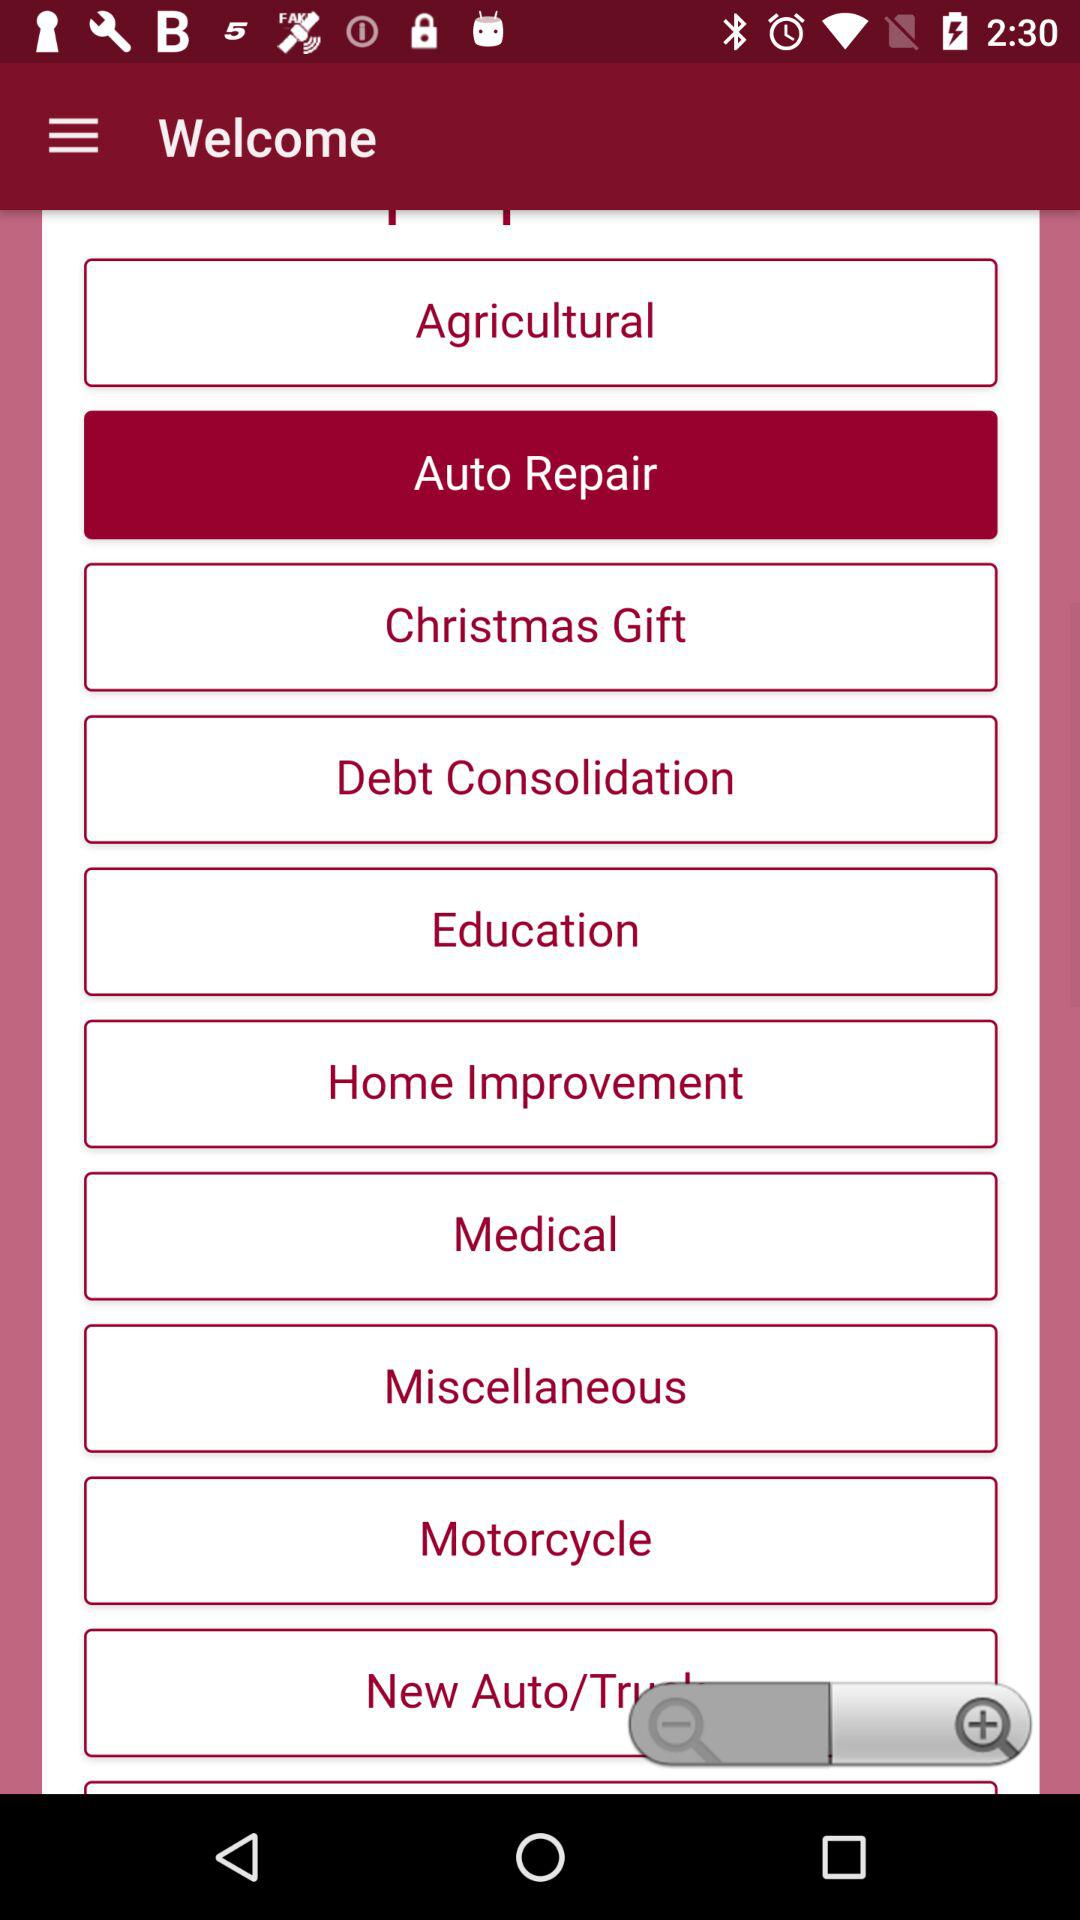Which category is selected? The selected category is "Auto Repair". 